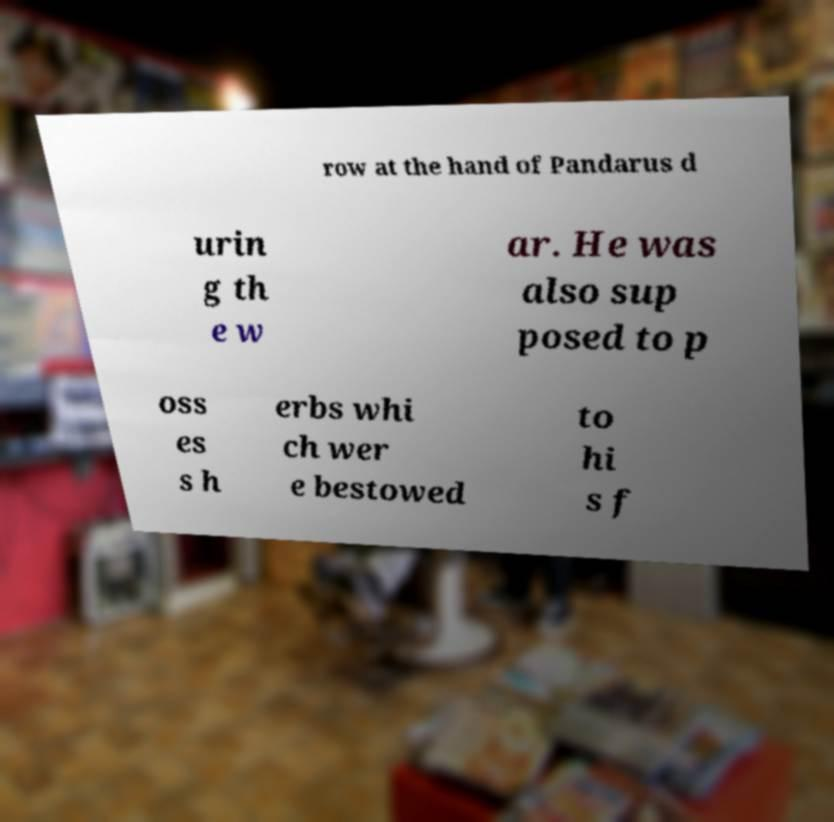Please read and relay the text visible in this image. What does it say? row at the hand of Pandarus d urin g th e w ar. He was also sup posed to p oss es s h erbs whi ch wer e bestowed to hi s f 